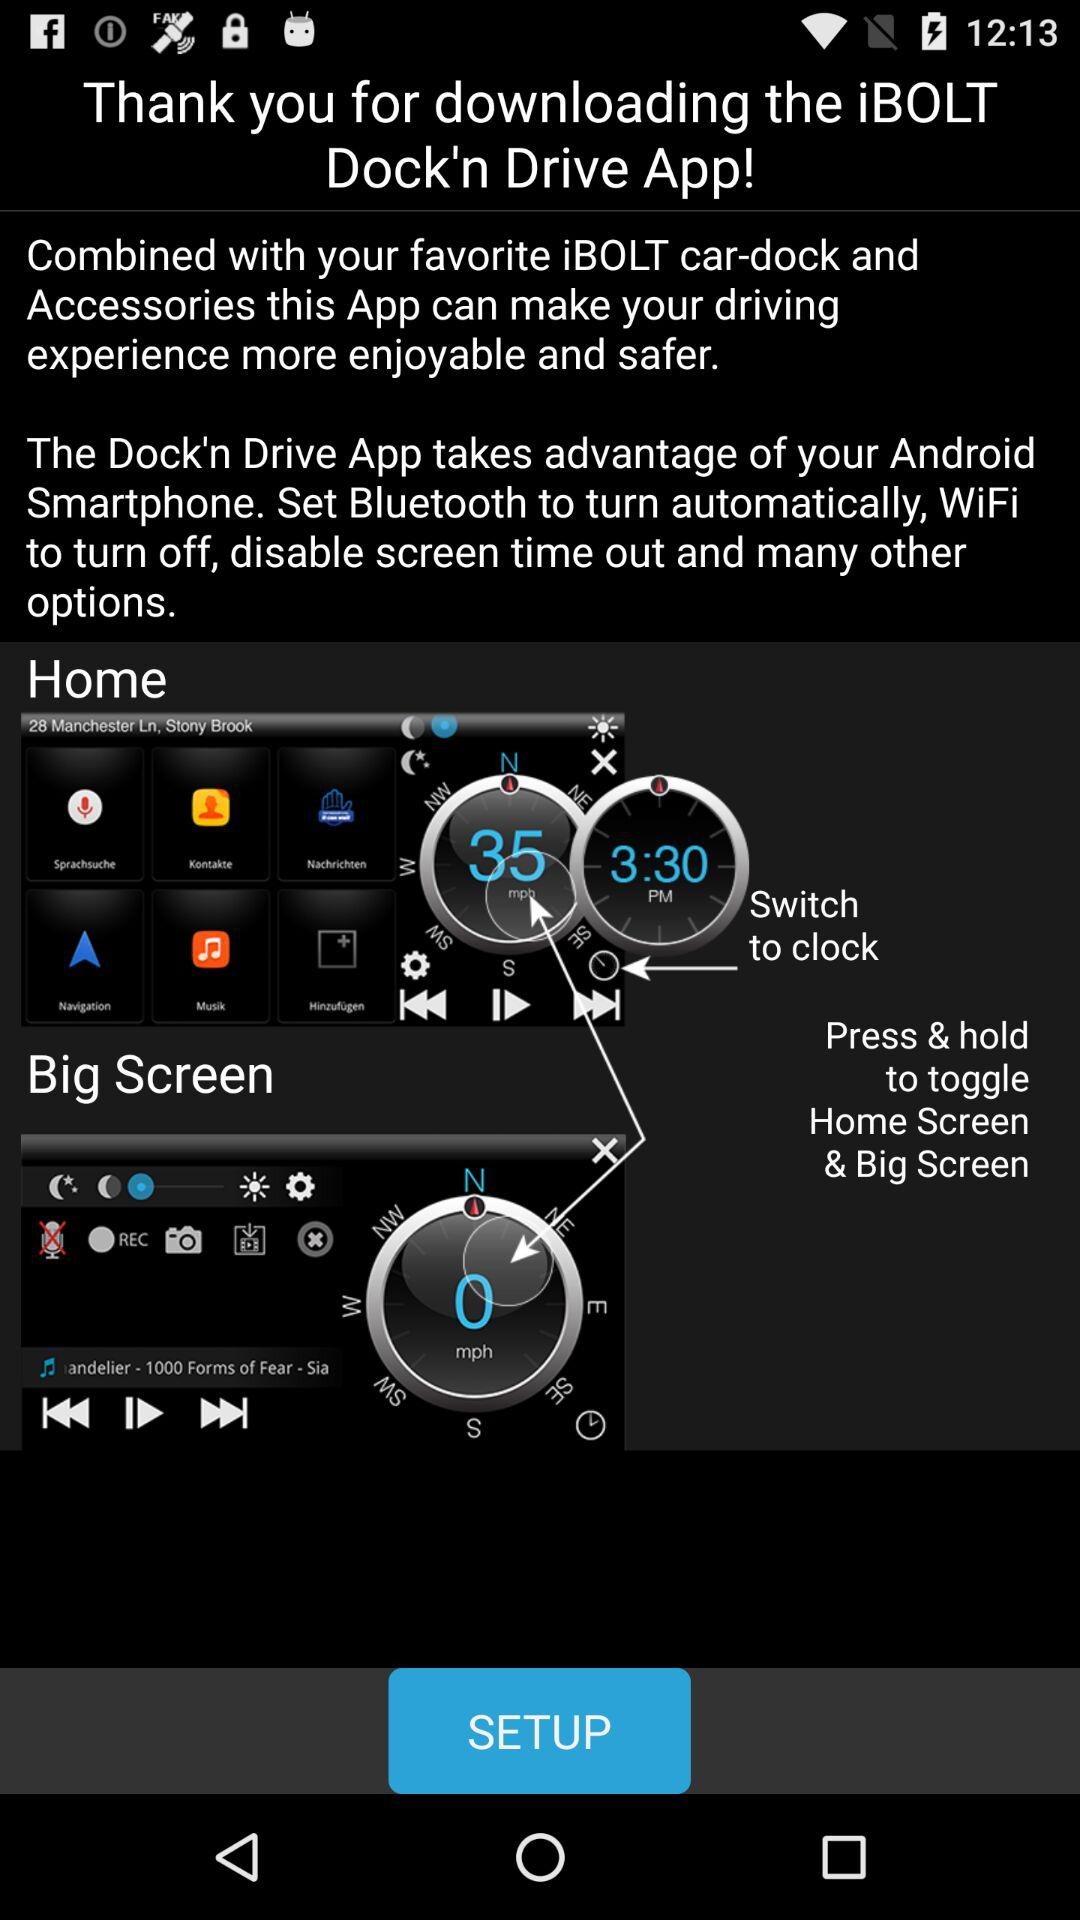What is the name of the application? The name of the application is "iBOLT Dock'n Drive". 